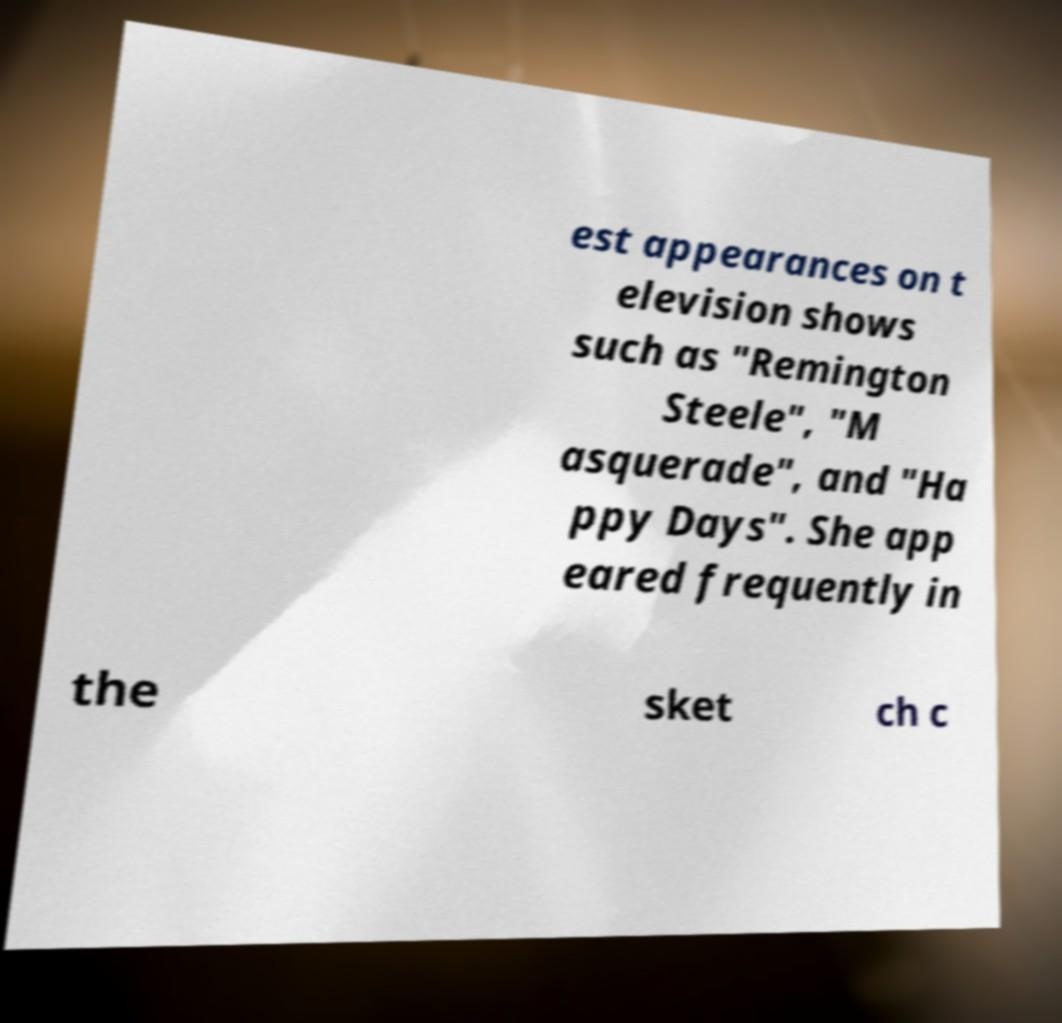Can you accurately transcribe the text from the provided image for me? est appearances on t elevision shows such as "Remington Steele", "M asquerade", and "Ha ppy Days". She app eared frequently in the sket ch c 